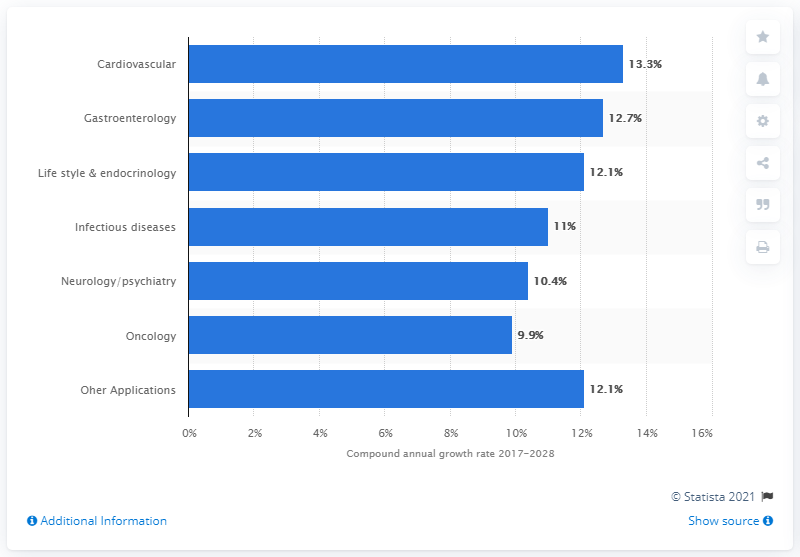Identify some key points in this picture. The CAGR (compound annual growth rate) of the global precision medicine market within oncology from 2017 to 2028 is expected to be 9.9%. 